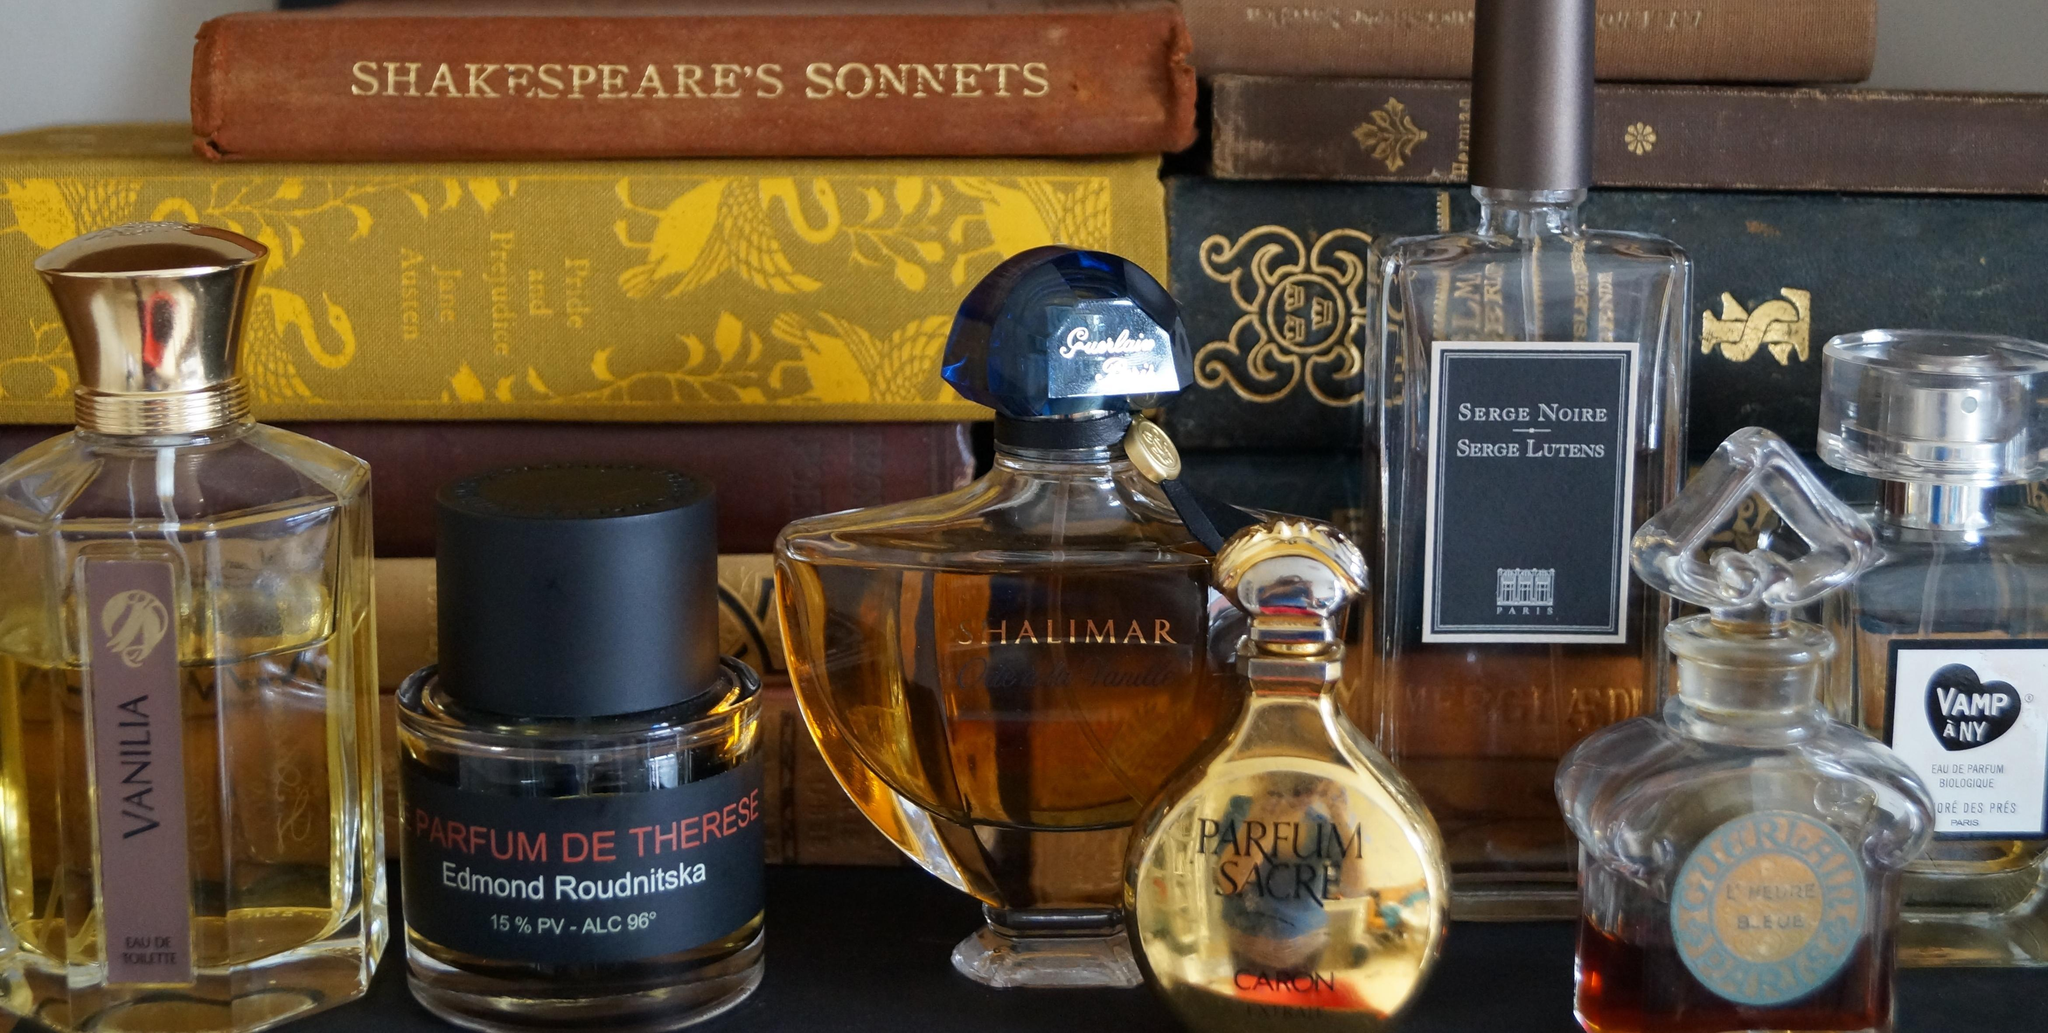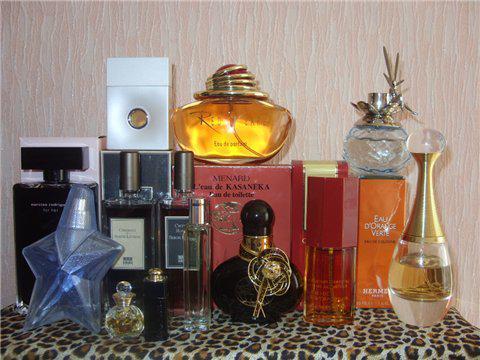The first image is the image on the left, the second image is the image on the right. Analyze the images presented: Is the assertion "One image shows a single squarish bottle to the right of its upright case." valid? Answer yes or no. No. The first image is the image on the left, the second image is the image on the right. For the images shown, is this caption "One of the images shows a single bottle of perfume standing next to its package." true? Answer yes or no. No. 